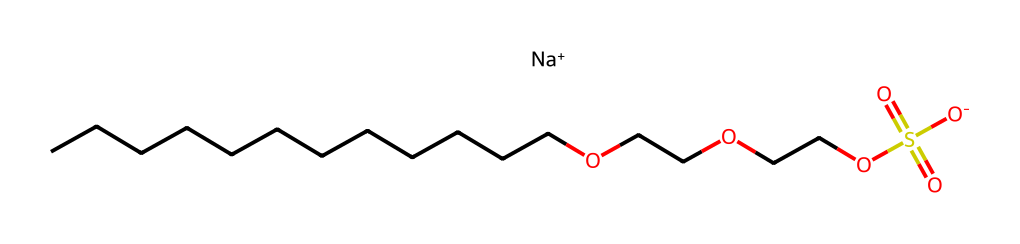What is the main ionic component of sodium laureth sulfate? The SMILES notation indicates the presence of "Na+" at the end, which signifies that sodium is the main ionic component of this molecule.
Answer: sodium How many carbon atoms are present in the structure? Counting the "C" in the aliphatic carbon chain (CCCCCCCCCCCC), there are 12 carbon atoms in total present.
Answer: 12 What functional group is present in sodium laureth sulfate that indicates it is a sulfate? The presence of "S(=O)(=O)[O-]" shows that there are sulfur atoms bonded to oxygen atoms in a specific configuration, characteristic of sulfate functional groups.
Answer: sulfate Which part of the structure is responsible for its surfactant properties? The long hydrocarbon chain (CCCCCCCCCCCC) contributes to its hydrophobic nature, while the sulfate group provides the hydrophilic characteristic, making it an effective surfactant.
Answer: long hydrocarbon chain and sulfate group What is the total number of oxygen atoms in the molecule? From the formula part "OCCOCCOS(=O)(=O)[O-]", there are 6 oxygen atoms total: 2 from the ether chain and 3 from the sulfate group.
Answer: 6 What kind of detergent is sodium laureth sulfate categorized as? This compound is categorized as an anionic detergent due to the negatively charged sulfate group in its structure.
Answer: anionic 